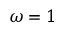Convert formula to latex. <formula><loc_0><loc_0><loc_500><loc_500>\omega = 1</formula> 